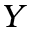Convert formula to latex. <formula><loc_0><loc_0><loc_500><loc_500>Y</formula> 